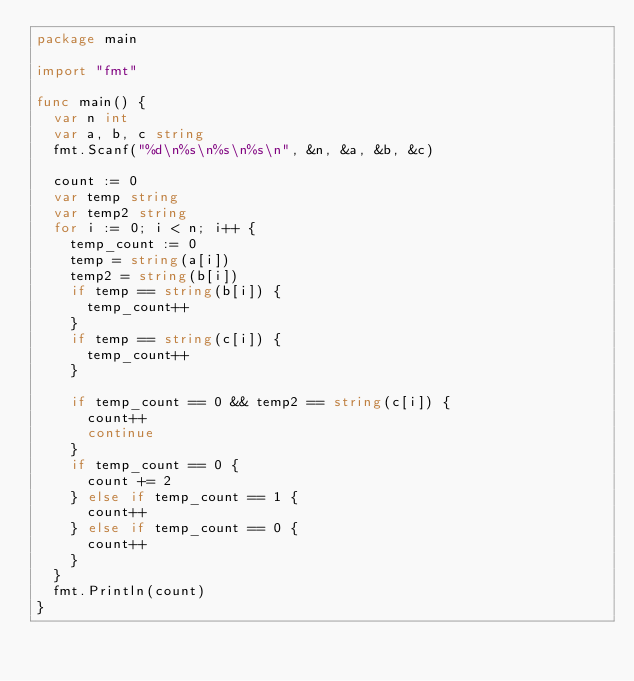Convert code to text. <code><loc_0><loc_0><loc_500><loc_500><_Go_>package main

import "fmt"

func main() {
	var n int
	var a, b, c string
	fmt.Scanf("%d\n%s\n%s\n%s\n", &n, &a, &b, &c)

	count := 0
	var temp string
	var temp2 string
	for i := 0; i < n; i++ {
		temp_count := 0
		temp = string(a[i])
		temp2 = string(b[i])
		if temp == string(b[i]) {
			temp_count++
		}
		if temp == string(c[i]) {
			temp_count++
		}

		if temp_count == 0 && temp2 == string(c[i]) {
			count++
			continue
		}
		if temp_count == 0 {
			count += 2
		} else if temp_count == 1 {
			count++
		} else if temp_count == 0 {
			count++
		}
	}
	fmt.Println(count)
}</code> 